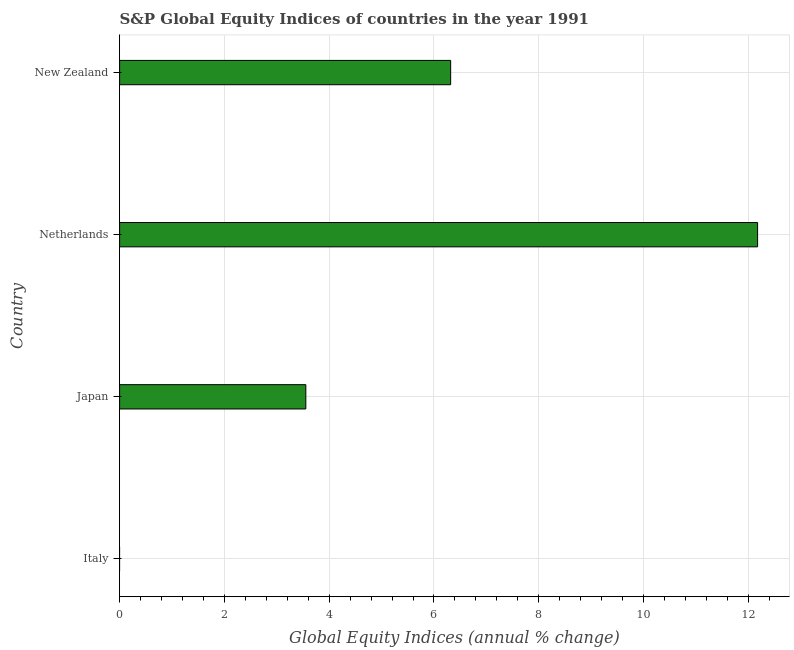Does the graph contain any zero values?
Your answer should be compact. Yes. Does the graph contain grids?
Provide a short and direct response. Yes. What is the title of the graph?
Your answer should be very brief. S&P Global Equity Indices of countries in the year 1991. What is the label or title of the X-axis?
Ensure brevity in your answer.  Global Equity Indices (annual % change). What is the s&p global equity indices in New Zealand?
Offer a very short reply. 6.32. Across all countries, what is the maximum s&p global equity indices?
Provide a short and direct response. 12.18. Across all countries, what is the minimum s&p global equity indices?
Provide a succinct answer. 0. What is the sum of the s&p global equity indices?
Offer a terse response. 22.05. What is the difference between the s&p global equity indices in Japan and New Zealand?
Offer a terse response. -2.76. What is the average s&p global equity indices per country?
Make the answer very short. 5.51. What is the median s&p global equity indices?
Your response must be concise. 4.94. What is the ratio of the s&p global equity indices in Japan to that in Netherlands?
Your answer should be compact. 0.29. What is the difference between the highest and the second highest s&p global equity indices?
Your response must be concise. 5.86. What is the difference between the highest and the lowest s&p global equity indices?
Ensure brevity in your answer.  12.18. In how many countries, is the s&p global equity indices greater than the average s&p global equity indices taken over all countries?
Provide a short and direct response. 2. Are all the bars in the graph horizontal?
Provide a short and direct response. Yes. What is the difference between two consecutive major ticks on the X-axis?
Offer a terse response. 2. Are the values on the major ticks of X-axis written in scientific E-notation?
Your answer should be compact. No. What is the Global Equity Indices (annual % change) of Italy?
Offer a very short reply. 0. What is the Global Equity Indices (annual % change) of Japan?
Give a very brief answer. 3.55. What is the Global Equity Indices (annual % change) in Netherlands?
Offer a very short reply. 12.18. What is the Global Equity Indices (annual % change) of New Zealand?
Your response must be concise. 6.32. What is the difference between the Global Equity Indices (annual % change) in Japan and Netherlands?
Your answer should be very brief. -8.62. What is the difference between the Global Equity Indices (annual % change) in Japan and New Zealand?
Ensure brevity in your answer.  -2.76. What is the difference between the Global Equity Indices (annual % change) in Netherlands and New Zealand?
Your answer should be compact. 5.86. What is the ratio of the Global Equity Indices (annual % change) in Japan to that in Netherlands?
Keep it short and to the point. 0.29. What is the ratio of the Global Equity Indices (annual % change) in Japan to that in New Zealand?
Give a very brief answer. 0.56. What is the ratio of the Global Equity Indices (annual % change) in Netherlands to that in New Zealand?
Your answer should be very brief. 1.93. 